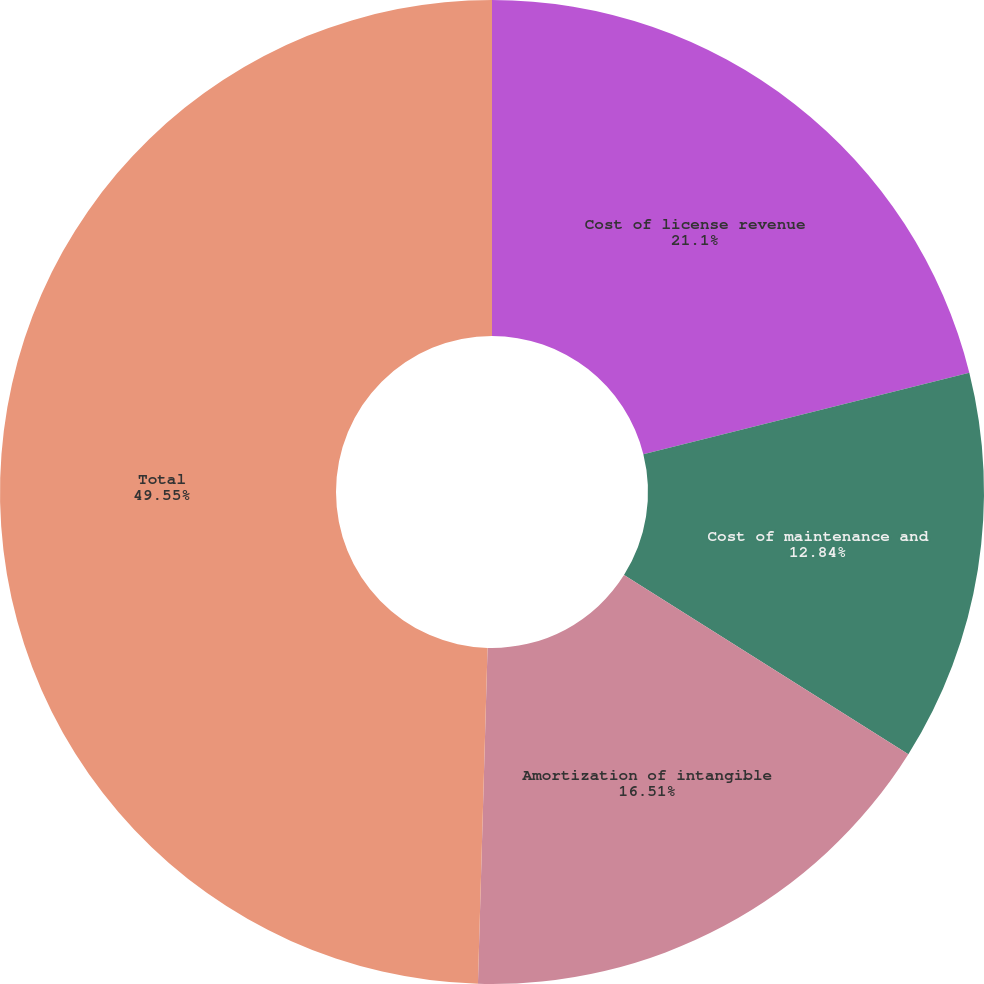Convert chart. <chart><loc_0><loc_0><loc_500><loc_500><pie_chart><fcel>Cost of license revenue<fcel>Cost of maintenance and<fcel>Amortization of intangible<fcel>Total<nl><fcel>21.1%<fcel>12.84%<fcel>16.51%<fcel>49.54%<nl></chart> 